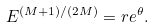Convert formula to latex. <formula><loc_0><loc_0><loc_500><loc_500>E ^ { ( M + 1 ) / ( 2 M ) } = r e ^ { \theta } .</formula> 